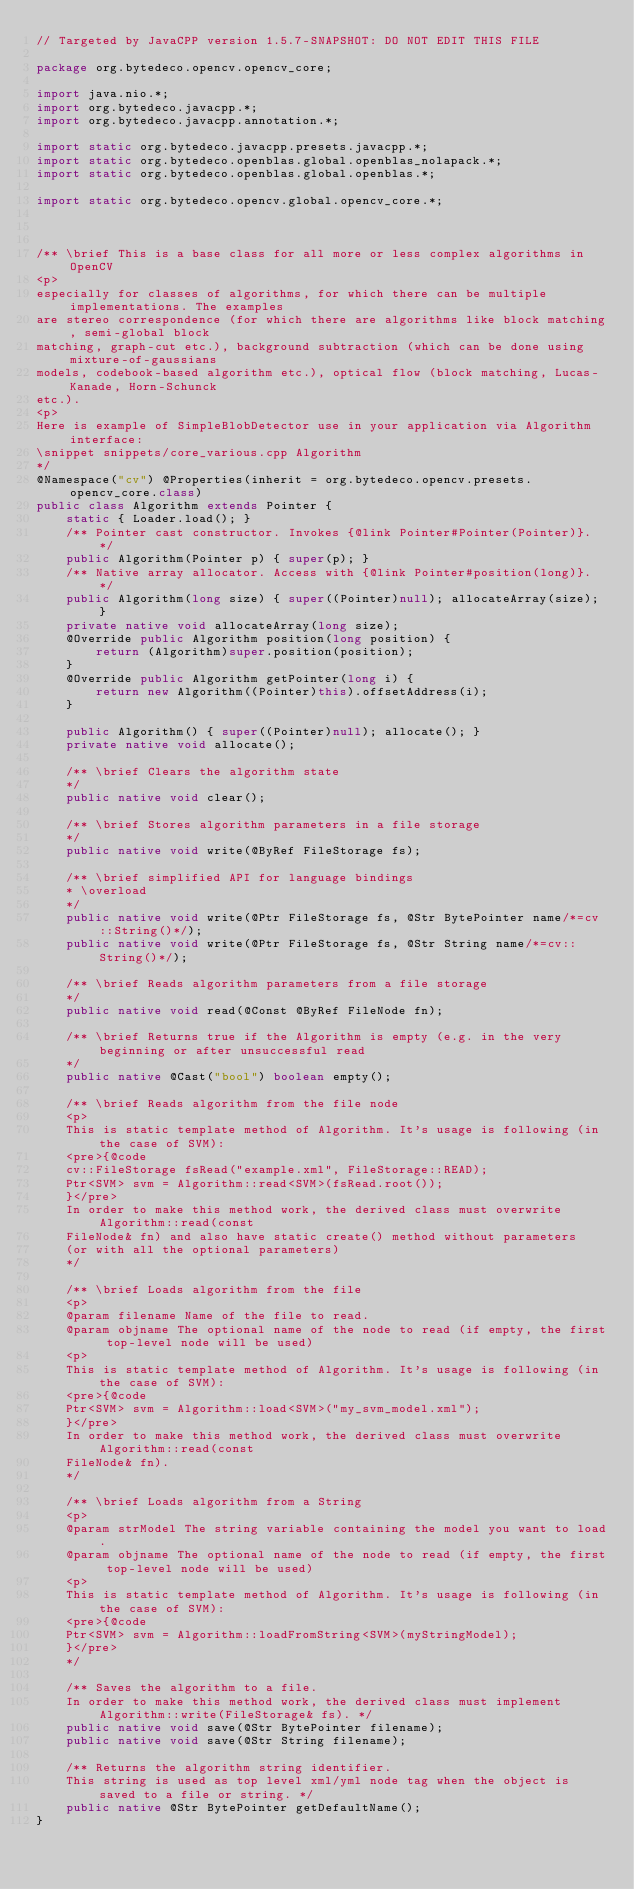<code> <loc_0><loc_0><loc_500><loc_500><_Java_>// Targeted by JavaCPP version 1.5.7-SNAPSHOT: DO NOT EDIT THIS FILE

package org.bytedeco.opencv.opencv_core;

import java.nio.*;
import org.bytedeco.javacpp.*;
import org.bytedeco.javacpp.annotation.*;

import static org.bytedeco.javacpp.presets.javacpp.*;
import static org.bytedeco.openblas.global.openblas_nolapack.*;
import static org.bytedeco.openblas.global.openblas.*;

import static org.bytedeco.opencv.global.opencv_core.*;



/** \brief This is a base class for all more or less complex algorithms in OpenCV
<p>
especially for classes of algorithms, for which there can be multiple implementations. The examples
are stereo correspondence (for which there are algorithms like block matching, semi-global block
matching, graph-cut etc.), background subtraction (which can be done using mixture-of-gaussians
models, codebook-based algorithm etc.), optical flow (block matching, Lucas-Kanade, Horn-Schunck
etc.).
<p>
Here is example of SimpleBlobDetector use in your application via Algorithm interface:
\snippet snippets/core_various.cpp Algorithm
*/
@Namespace("cv") @Properties(inherit = org.bytedeco.opencv.presets.opencv_core.class)
public class Algorithm extends Pointer {
    static { Loader.load(); }
    /** Pointer cast constructor. Invokes {@link Pointer#Pointer(Pointer)}. */
    public Algorithm(Pointer p) { super(p); }
    /** Native array allocator. Access with {@link Pointer#position(long)}. */
    public Algorithm(long size) { super((Pointer)null); allocateArray(size); }
    private native void allocateArray(long size);
    @Override public Algorithm position(long position) {
        return (Algorithm)super.position(position);
    }
    @Override public Algorithm getPointer(long i) {
        return new Algorithm((Pointer)this).offsetAddress(i);
    }

    public Algorithm() { super((Pointer)null); allocate(); }
    private native void allocate();

    /** \brief Clears the algorithm state
    */
    public native void clear();

    /** \brief Stores algorithm parameters in a file storage
    */
    public native void write(@ByRef FileStorage fs);

    /** \brief simplified API for language bindings
    * \overload
    */
    public native void write(@Ptr FileStorage fs, @Str BytePointer name/*=cv::String()*/);
    public native void write(@Ptr FileStorage fs, @Str String name/*=cv::String()*/);

    /** \brief Reads algorithm parameters from a file storage
    */
    public native void read(@Const @ByRef FileNode fn);

    /** \brief Returns true if the Algorithm is empty (e.g. in the very beginning or after unsuccessful read
    */
    public native @Cast("bool") boolean empty();

    /** \brief Reads algorithm from the file node
    <p>
    This is static template method of Algorithm. It's usage is following (in the case of SVM):
    <pre>{@code
    cv::FileStorage fsRead("example.xml", FileStorage::READ);
    Ptr<SVM> svm = Algorithm::read<SVM>(fsRead.root());
    }</pre>
    In order to make this method work, the derived class must overwrite Algorithm::read(const
    FileNode& fn) and also have static create() method without parameters
    (or with all the optional parameters)
    */

    /** \brief Loads algorithm from the file
    <p>
    @param filename Name of the file to read.
    @param objname The optional name of the node to read (if empty, the first top-level node will be used)
    <p>
    This is static template method of Algorithm. It's usage is following (in the case of SVM):
    <pre>{@code
    Ptr<SVM> svm = Algorithm::load<SVM>("my_svm_model.xml");
    }</pre>
    In order to make this method work, the derived class must overwrite Algorithm::read(const
    FileNode& fn).
    */

    /** \brief Loads algorithm from a String
    <p>
    @param strModel The string variable containing the model you want to load.
    @param objname The optional name of the node to read (if empty, the first top-level node will be used)
    <p>
    This is static template method of Algorithm. It's usage is following (in the case of SVM):
    <pre>{@code
    Ptr<SVM> svm = Algorithm::loadFromString<SVM>(myStringModel);
    }</pre>
    */

    /** Saves the algorithm to a file.
    In order to make this method work, the derived class must implement Algorithm::write(FileStorage& fs). */
    public native void save(@Str BytePointer filename);
    public native void save(@Str String filename);

    /** Returns the algorithm string identifier.
    This string is used as top level xml/yml node tag when the object is saved to a file or string. */
    public native @Str BytePointer getDefaultName();
}
</code> 